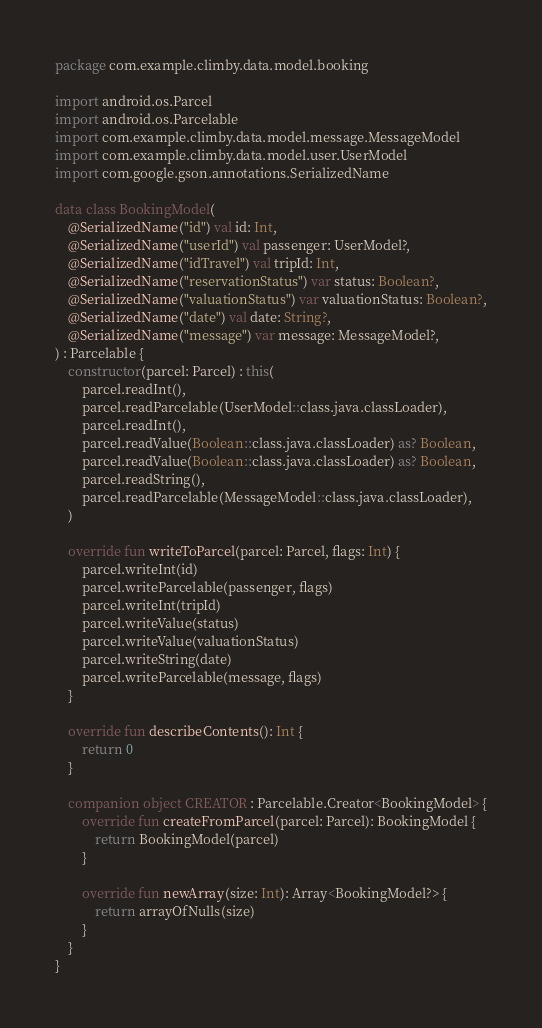Convert code to text. <code><loc_0><loc_0><loc_500><loc_500><_Kotlin_>package com.example.climby.data.model.booking

import android.os.Parcel
import android.os.Parcelable
import com.example.climby.data.model.message.MessageModel
import com.example.climby.data.model.user.UserModel
import com.google.gson.annotations.SerializedName

data class BookingModel(
    @SerializedName("id") val id: Int,
    @SerializedName("userId") val passenger: UserModel?,
    @SerializedName("idTravel") val tripId: Int,
    @SerializedName("reservationStatus") var status: Boolean?,
    @SerializedName("valuationStatus") var valuationStatus: Boolean?,
    @SerializedName("date") val date: String?,
    @SerializedName("message") var message: MessageModel?,
) : Parcelable {
    constructor(parcel: Parcel) : this(
        parcel.readInt(),
        parcel.readParcelable(UserModel::class.java.classLoader),
        parcel.readInt(),
        parcel.readValue(Boolean::class.java.classLoader) as? Boolean,
        parcel.readValue(Boolean::class.java.classLoader) as? Boolean,
        parcel.readString(),
        parcel.readParcelable(MessageModel::class.java.classLoader),
    )

    override fun writeToParcel(parcel: Parcel, flags: Int) {
        parcel.writeInt(id)
        parcel.writeParcelable(passenger, flags)
        parcel.writeInt(tripId)
        parcel.writeValue(status)
        parcel.writeValue(valuationStatus)
        parcel.writeString(date)
        parcel.writeParcelable(message, flags)
    }

    override fun describeContents(): Int {
        return 0
    }

    companion object CREATOR : Parcelable.Creator<BookingModel> {
        override fun createFromParcel(parcel: Parcel): BookingModel {
            return BookingModel(parcel)
        }

        override fun newArray(size: Int): Array<BookingModel?> {
            return arrayOfNulls(size)
        }
    }
}

</code> 